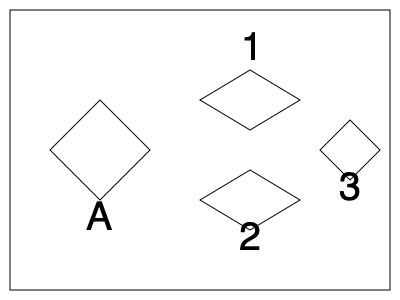Which of the heat-affected steam engine parts (1, 2, or 3) represents the original shape A after being subjected to high temperatures and rotated? Consider the potential deformation due to thermal expansion. To solve this problem, we need to consider the effects of high temperature on the steam engine component and mentally rotate the given shapes. Let's approach this step-by-step:

1. Observe the original shape A: It's a diamond-shaped quadrilateral with equal sides.

2. Consider the effects of high temperature:
   - Thermal expansion typically causes materials to expand uniformly in all directions.
   - The overall shape should remain similar, but slightly larger.

3. Analyze the given heat-affected shapes:
   - Shape 1: Appears to be a compressed version of A, rotated about 45° clockwise.
   - Shape 2: Looks like an expanded version of A, rotated about 45° clockwise.
   - Shape 3: Seems to be a slightly compressed version of A, rotated about 90° clockwise.

4. Compare the proportions:
   - Shape 1 is too compressed to be the result of thermal expansion.
   - Shape 2 maintains the proportions of A but is larger, consistent with thermal expansion.
   - Shape 3 is slightly compressed and smaller, which is inconsistent with thermal expansion.

5. Consider the rotation:
   - Shape 2 is rotated 45° clockwise from the original position of A.

Given that shape 2 maintains the proportions of A while being slightly larger (consistent with thermal expansion) and is rotated 45° clockwise, it is the most likely candidate to represent the heat-affected and rotated version of the original shape A.
Answer: 2 